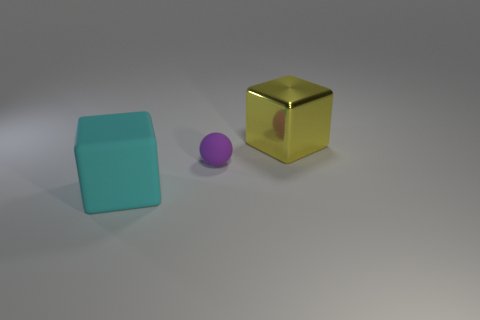Add 1 green spheres. How many objects exist? 4 Subtract all cubes. How many objects are left? 1 Add 1 small rubber things. How many small rubber things exist? 2 Subtract 0 gray cylinders. How many objects are left? 3 Subtract all large cyan rubber things. Subtract all big rubber blocks. How many objects are left? 1 Add 2 big cubes. How many big cubes are left? 4 